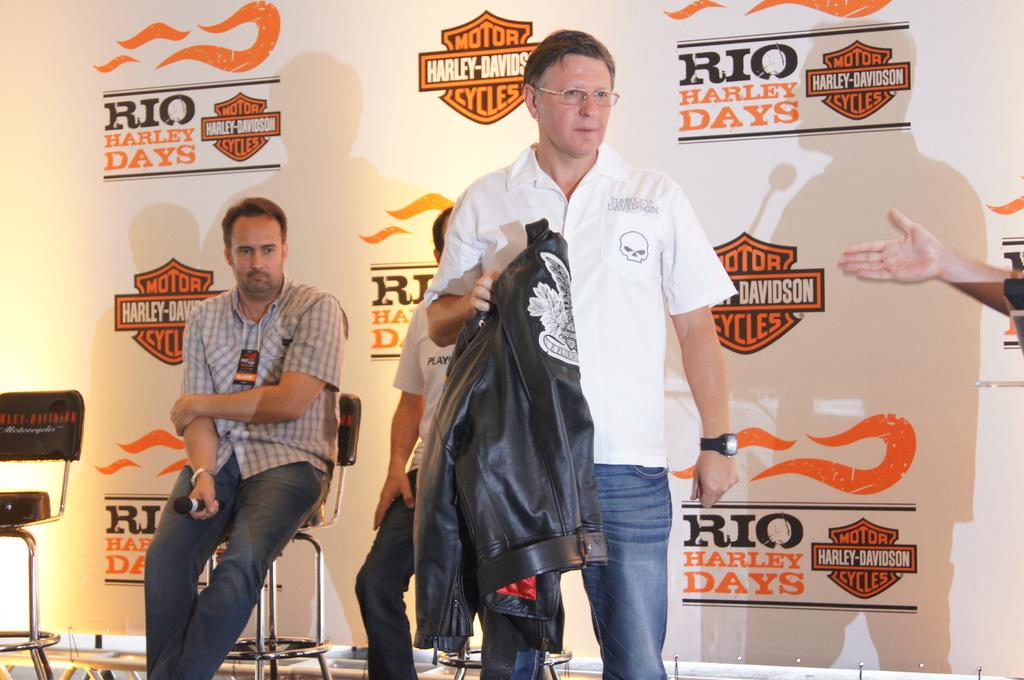What are the people in the image doing? The people in the image are sitting on chairs. Is there anyone standing in the image? Yes, there is a person standing in the image. What is the standing person holding? The standing person is holding a jacket. Can you see any body parts other than the standing person's hand in the image? Yes, a person's hand is visible in the image. What is in the background of the image? There is a banner in the background of the image. What type of yarn is being used by the geese in the image? There are no geese or yarn present in the image. What news event is being discussed by the people in the image? The image does not provide any information about a news event or discussion among the people. 